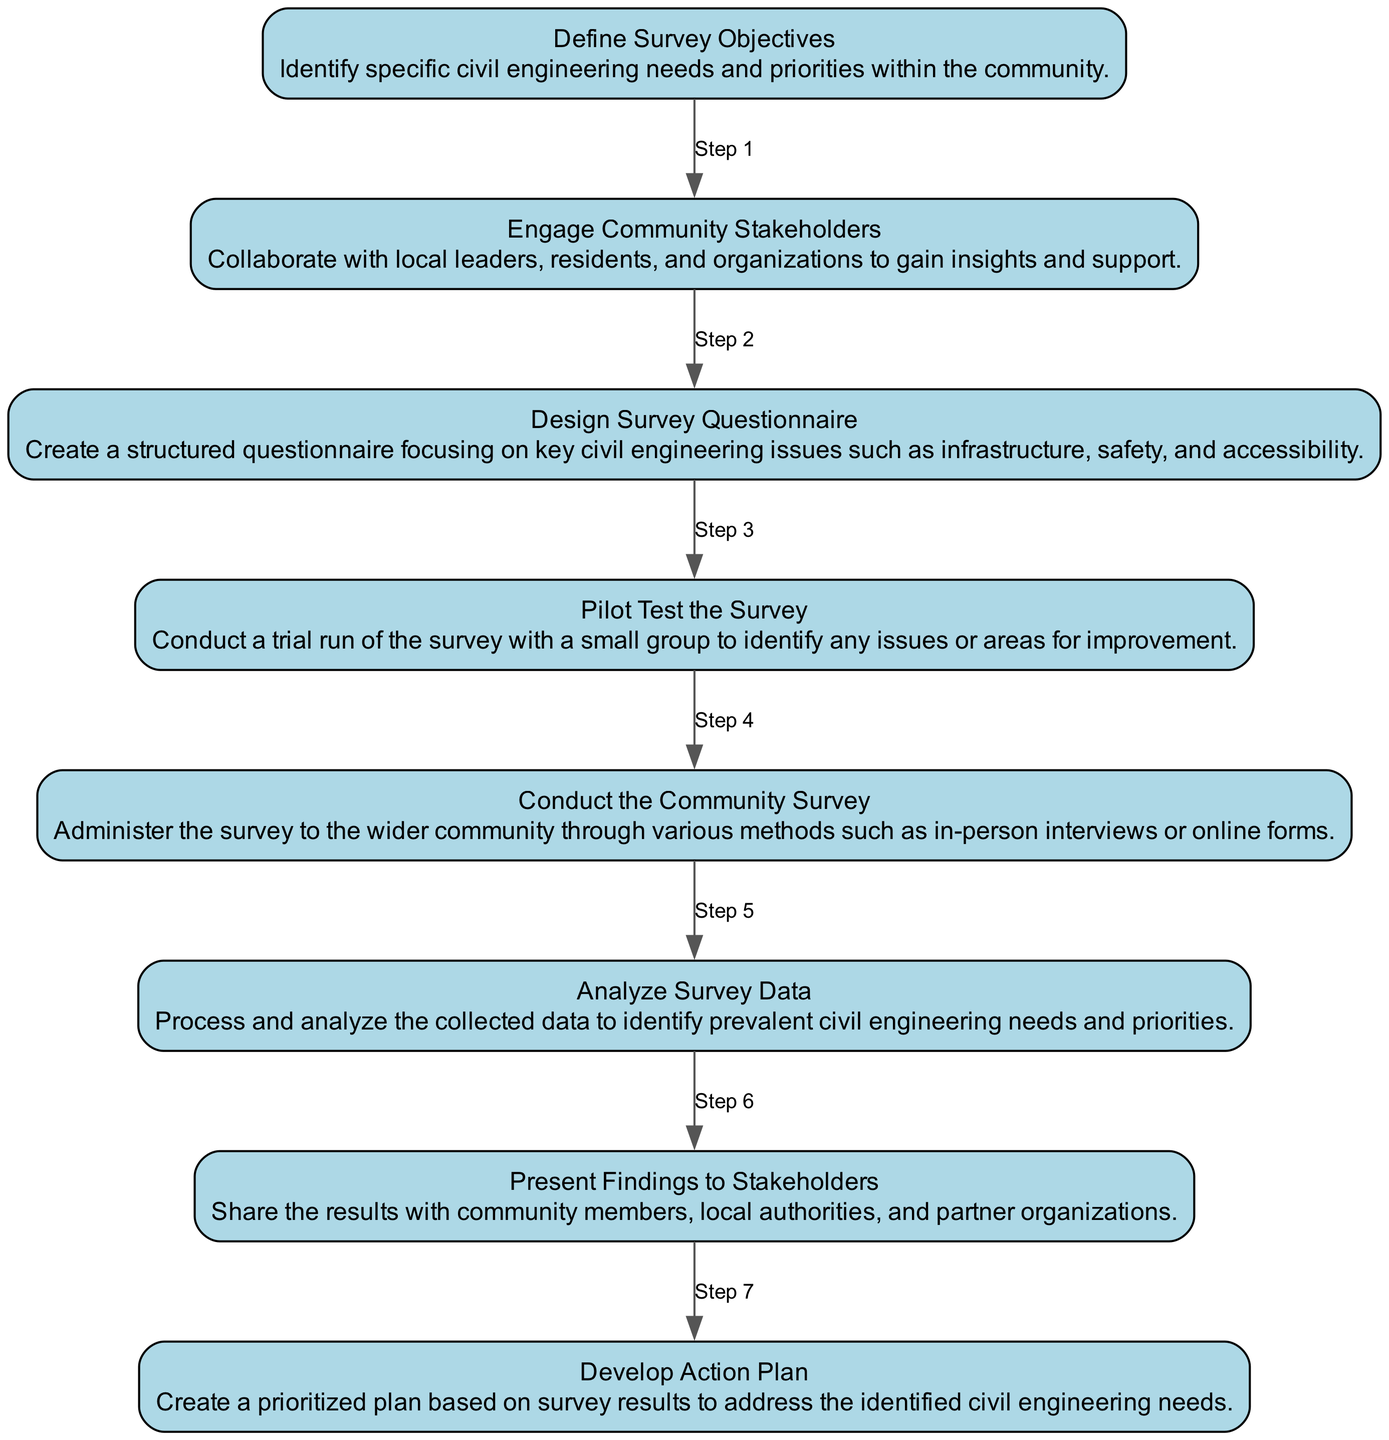What is the first activity in the sequence? The first activity listed in the diagram is "Define Survey Objectives." It serves as the starting point of the sequence of activities.
Answer: Define Survey Objectives How many activities are present in the diagram? The diagram consists of eight activities in total, each representing a step in the community survey process.
Answer: 8 What activity comes after "Pilot Test the Survey"? The activity that follows "Pilot Test the Survey" is "Conduct the Community Survey." It represents the transition from testing to full implementation.
Answer: Conduct the Community Survey What is the main goal of the “Analyze Survey Data” activity? The goal of the "Analyze Survey Data" activity is to process and analyze collected data to identify prevalent civil engineering needs and priorities.
Answer: To identify prevalent civil engineering needs and priorities Which two activities are connected directly by an edge labeled as "Step 6"? The edge labeled as "Step 6" connects "Conduct the Community Survey" and "Analyze Survey Data," indicating the direct relationship between administering the survey and analyzing its results.
Answer: Conduct the Community Survey and Analyze Survey Data What is the last activity in the sequence? The last activity in the sequence is "Develop Action Plan," concluding the sequence of activities aimed at addressing civil engineering needs.
Answer: Develop Action Plan How does “Engage Community Stakeholders” relate to the overall sequence? "Engage Community Stakeholders" is crucial as it sets a foundation for support and collaboration, impacting the success of subsequent activities in the surveying process.
Answer: It establishes foundation and support Which activity serves as a feedback loop in this sequence? "Pilot Test the Survey" serves as a feedback loop as it aims to identify issues before conducting the full survey, helping to refine subsequent activities.
Answer: Pilot Test the Survey 